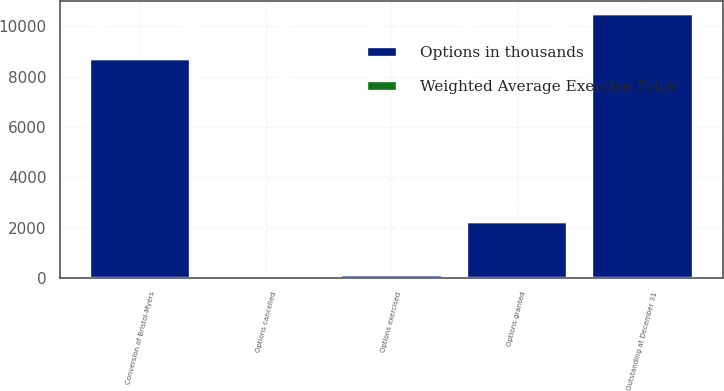Convert chart to OTSL. <chart><loc_0><loc_0><loc_500><loc_500><stacked_bar_chart><ecel><fcel>Conversion of Bristol-Myers<fcel>Options granted<fcel>Options exercised<fcel>Options cancelled<fcel>Outstanding at December 31<nl><fcel>Options in thousands<fcel>8700<fcel>2239<fcel>129<fcel>83<fcel>10470<nl><fcel>Weighted Average Exercise Price<fcel>23.93<fcel>28.67<fcel>12.8<fcel>29.88<fcel>30.77<nl></chart> 